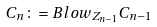Convert formula to latex. <formula><loc_0><loc_0><loc_500><loc_500>C _ { n } \colon = B l o w _ { Z _ { n - 1 } } C _ { n - 1 }</formula> 